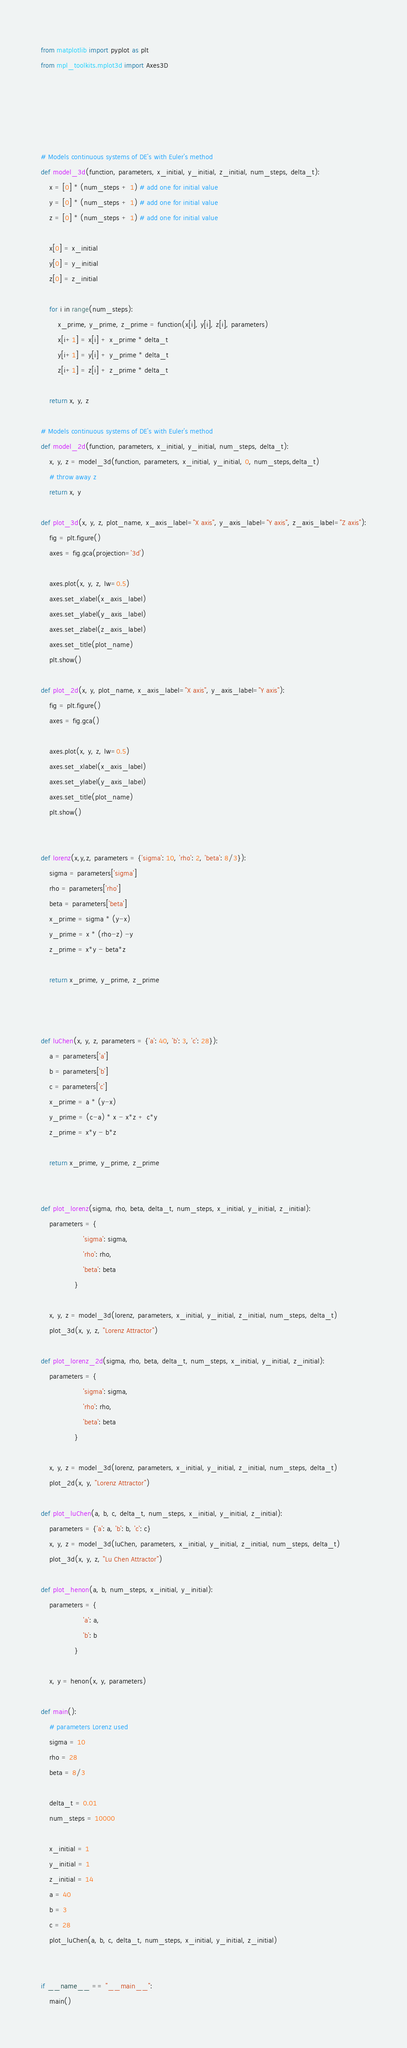Convert code to text. <code><loc_0><loc_0><loc_500><loc_500><_Python_>from matplotlib import pyplot as plt
from mpl_toolkits.mplot3d import Axes3D





# Models continuous systems of DE's with Euler's method
def model_3d(function, parameters, x_initial, y_initial, z_initial, num_steps, delta_t):
    x = [0] * (num_steps + 1) # add one for initial value
    y = [0] * (num_steps + 1) # add one for initial value
    z = [0] * (num_steps + 1) # add one for initial value

    x[0] = x_initial
    y[0] = y_initial
    z[0] = z_initial

    for i in range(num_steps):
        x_prime, y_prime, z_prime = function(x[i], y[i], z[i], parameters)
        x[i+1] = x[i] + x_prime * delta_t
        y[i+1] = y[i] + y_prime * delta_t
        z[i+1] = z[i] + z_prime * delta_t

    return x, y, z

# Models continuous systems of DE's with Euler's method
def model_2d(function, parameters, x_initial, y_initial, num_steps, delta_t):
    x, y, z = model_3d(function, parameters, x_initial, y_initial, 0, num_steps,delta_t)
    # throw away z
    return x, y

def plot_3d(x, y, z, plot_name, x_axis_label="X axis", y_axis_label="Y axis", z_axis_label="Z axis"):
    fig = plt.figure()
    axes = fig.gca(projection='3d')

    axes.plot(x, y, z, lw=0.5)
    axes.set_xlabel(x_axis_label)
    axes.set_ylabel(y_axis_label)
    axes.set_zlabel(z_axis_label)
    axes.set_title(plot_name)
    plt.show()

def plot_2d(x, y, plot_name, x_axis_label="X axis", y_axis_label="Y axis"):
    fig = plt.figure()
    axes = fig.gca()

    axes.plot(x, y, z, lw=0.5)
    axes.set_xlabel(x_axis_label)
    axes.set_ylabel(y_axis_label)
    axes.set_title(plot_name)
    plt.show()


def lorenz(x,y,z, parameters = {'sigma': 10, 'rho': 2, 'beta': 8/3}):
    sigma = parameters['sigma']
    rho = parameters['rho']
    beta = parameters['beta']
    x_prime = sigma * (y-x)
    y_prime = x * (rho-z) -y
    z_prime = x*y - beta*z

    return x_prime, y_prime, z_prime



def luChen(x, y, z, parameters = {'a': 40, 'b': 3, 'c': 28}):
    a = parameters['a']
    b = parameters['b']
    c = parameters['c']
    x_prime = a * (y-x)
    y_prime = (c-a) * x - x*z + c*y
    z_prime = x*y - b*z

    return x_prime, y_prime, z_prime


def plot_lorenz(sigma, rho, beta, delta_t, num_steps, x_initial, y_initial, z_initial):
    parameters = {
                    'sigma': sigma,
                    'rho': rho,
                    'beta': beta
                }

    x, y, z = model_3d(lorenz, parameters, x_initial, y_initial, z_initial, num_steps, delta_t)
    plot_3d(x, y, z, "Lorenz Attractor")

def plot_lorenz_2d(sigma, rho, beta, delta_t, num_steps, x_initial, y_initial, z_initial):
    parameters = {
                    'sigma': sigma,
                    'rho': rho,
                    'beta': beta
                }

    x, y, z = model_3d(lorenz, parameters, x_initial, y_initial, z_initial, num_steps, delta_t)
    plot_2d(x, y, "Lorenz Attractor")

def plot_luChen(a, b, c, delta_t, num_steps, x_initial, y_initial, z_initial):
    parameters = {'a': a, 'b': b, 'c': c}
    x, y, z = model_3d(luChen, parameters, x_initial, y_initial, z_initial, num_steps, delta_t)
    plot_3d(x, y, z, "Lu Chen Attractor")

def plot_henon(a, b, num_steps, x_initial, y_initial):
    parameters = {
                    'a': a,
                    'b': b
                }

    x, y = henon(x, y, parameters)

def main():
    # parameters Lorenz used
    sigma = 10
    rho = 28
    beta = 8/3

    delta_t = 0.01
    num_steps = 10000

    x_initial = 1
    y_initial = 1
    z_initial = 14
    a = 40
    b = 3
    c = 28
    plot_luChen(a, b, c, delta_t, num_steps, x_initial, y_initial, z_initial)


if __name__ == "__main__":
    main()</code> 